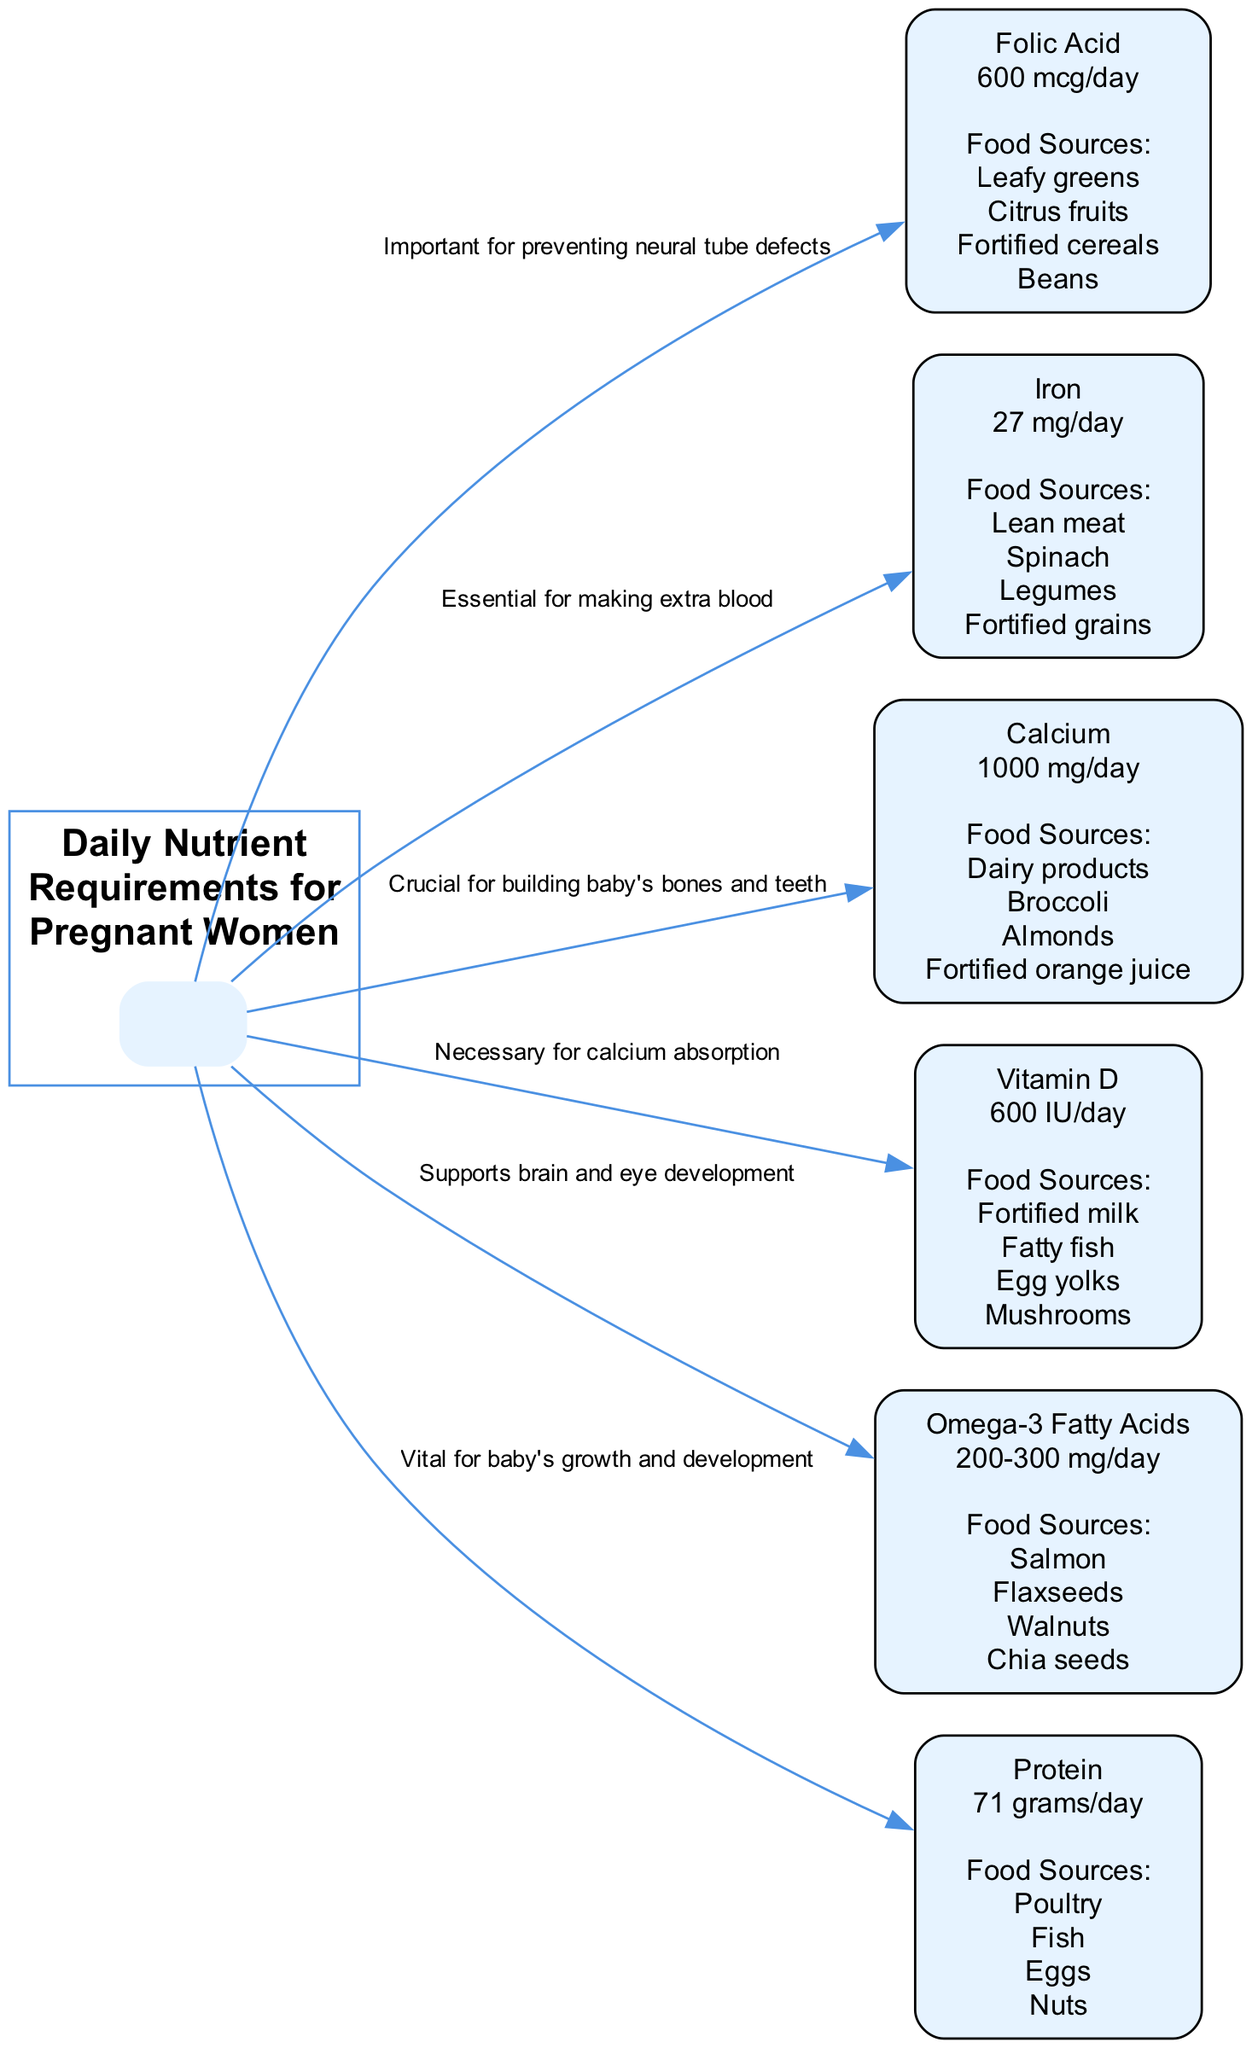What is the daily requirement of Folic Acid for pregnant women? The diagram specifies that the daily requirement for Folic Acid is indicated right beneath its label, showing "600 mcg/day".
Answer: 600 mcg/day How many food sources are listed for Calcium? The Calcium node lists four food sources: Dairy products, Broccoli, Almonds, and Fortified orange juice, which can be counted directly from the diagram.
Answer: 4 What nutrient is essential for making extra blood? The diagram states that Iron is "Essential for making extra blood" next to its node, thus providing the required information.
Answer: Iron What is the daily requirement of Protein for pregnant women? The Protein node clearly shows the requirement as "71 grams/day", which directly answers the question.
Answer: 71 grams/day Which nutrient supports brain and eye development? According to the diagram, Omega-3 Fatty Acids is labeled as important for brain and eye development, clearly indicated near its node in the edges.
Answer: Omega-3 Fatty Acids What food sources are recommended for obtaining Iron? The Iron node lists Lean meat, Spinach, Legumes, and Fortified grains as food sources, which can be seen directly from that node's content.
Answer: Lean meat, Spinach, Legumes, Fortified grains What nutrient is necessary for calcium absorption? The diagram directly states that Vitamin D is "Necessary for calcium absorption," shown right by the Vitamin D label in the edges section.
Answer: Vitamin D How many edges are connecting the nutrients to their important roles? By counting the edges from the diagram, there are six connections illustrated that link nutrients to their important roles.
Answer: 6 